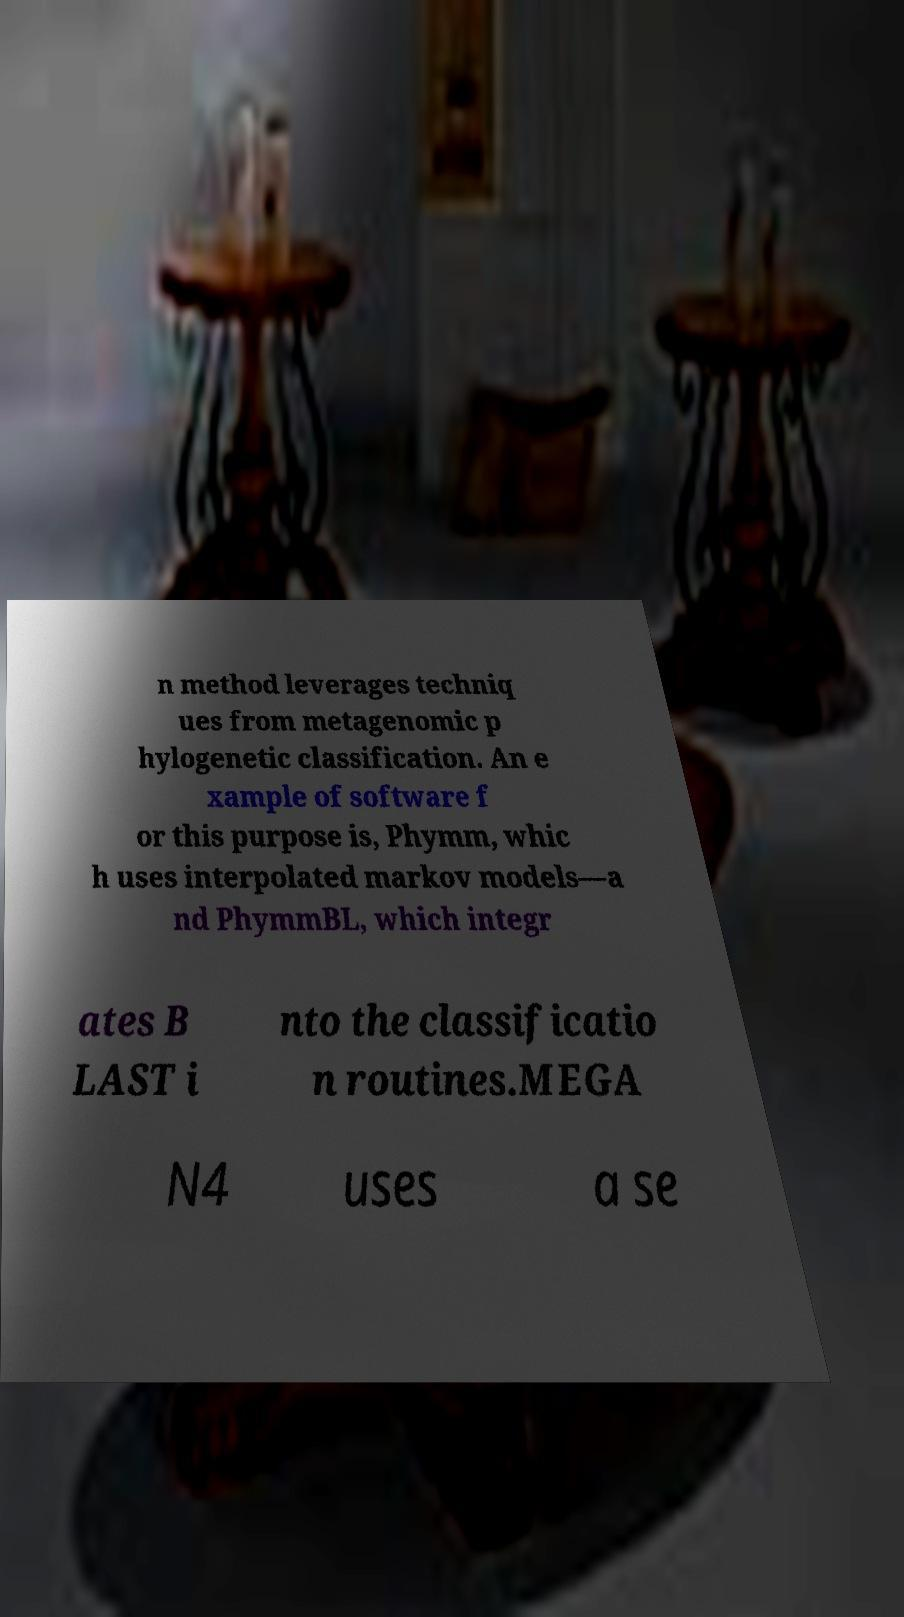There's text embedded in this image that I need extracted. Can you transcribe it verbatim? n method leverages techniq ues from metagenomic p hylogenetic classification. An e xample of software f or this purpose is, Phymm, whic h uses interpolated markov models—a nd PhymmBL, which integr ates B LAST i nto the classificatio n routines.MEGA N4 uses a se 